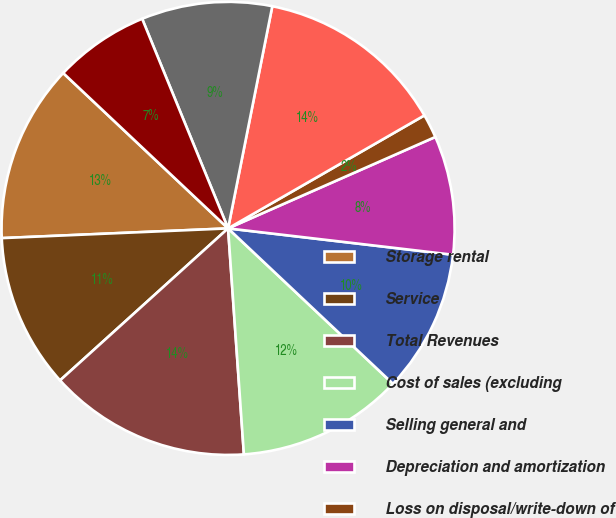<chart> <loc_0><loc_0><loc_500><loc_500><pie_chart><fcel>Storage rental<fcel>Service<fcel>Total Revenues<fcel>Cost of sales (excluding<fcel>Selling general and<fcel>Depreciation and amortization<fcel>Loss on disposal/write-down of<fcel>Total Operating Expenses<fcel>Operating Income<fcel>Interest Expense Net<nl><fcel>12.71%<fcel>11.02%<fcel>14.41%<fcel>11.86%<fcel>10.17%<fcel>8.47%<fcel>1.7%<fcel>13.56%<fcel>9.32%<fcel>6.78%<nl></chart> 